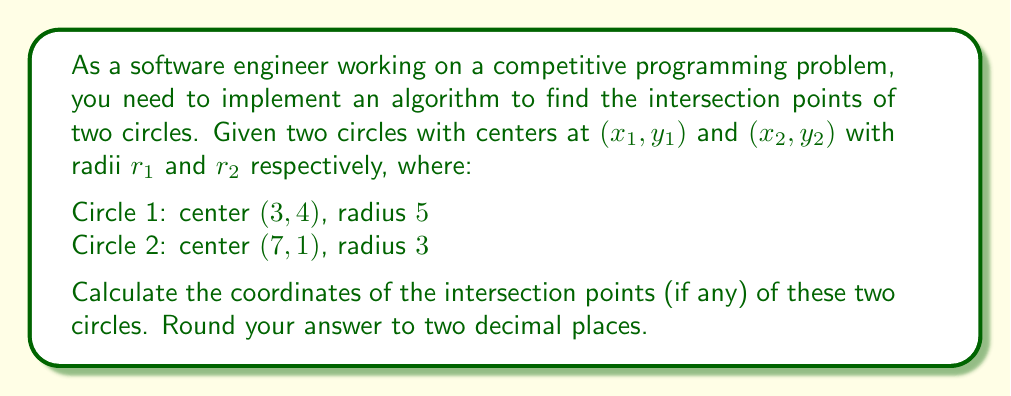Help me with this question. To solve this problem, we'll follow these steps:

1) First, calculate the distance $d$ between the centers of the two circles using the distance formula:

   $$d = \sqrt{(x_2 - x_1)^2 + (y_2 - y_1)^2}$$
   $$d = \sqrt{(7 - 3)^2 + (1 - 4)^2} = \sqrt{16 + 9} = 5$$

2) Next, we need to check if the circles intersect. They will intersect if:
   $|r_1 - r_2| < d < r_1 + r_2$

   In this case: $5 - 3 < 5 < 5 + 3$, so they do intersect.

3) Now, we can use the following formulas to find the intersection points:

   $$a = \frac{r_1^2 - r_2^2 + d^2}{2d}$$
   $$h = \sqrt{r_1^2 - a^2}$$

   $$x_3 = x_1 + a\frac{x_2 - x_1}{d}$$
   $$y_3 = y_1 + a\frac{y_2 - y_1}{d}$$

   $$x_4 = x_3 \pm h\frac{y_2 - y_1}{d}$$
   $$y_4 = y_3 \mp h\frac{x_2 - x_1}{d}$$

4) Let's calculate these values:

   $$a = \frac{5^2 - 3^2 + 5^2}{2(5)} = \frac{25 - 9 + 25}{10} = 4.1$$
   $$h = \sqrt{5^2 - 4.1^2} = \sqrt{25 - 16.81} = 2.943$$

   $$x_3 = 3 + 4.1\frac{7 - 3}{5} = 3 + 3.28 = 6.28$$
   $$y_3 = 4 + 4.1\frac{1 - 4}{5} = 4 - 2.46 = 1.54$$

5) Now for the intersection points:

   $$x_4 = 6.28 \pm 2.943\frac{1 - 4}{5} = 6.28 \mp 1.7658$$
   $$y_4 = 1.54 \mp 2.943\frac{7 - 3}{5} = 1.54 \pm 2.3544$$

6) This gives us two points:

   $(6.28 + 1.7658, 1.54 - 2.3544) = (8.05, -0.81)$
   $(6.28 - 1.7658, 1.54 + 2.3544) = (4.51, 3.89)$

Rounding to two decimal places gives us the final answer.
Answer: The intersection points of the two circles are approximately (8.05, -0.81) and (4.51, 3.89). 